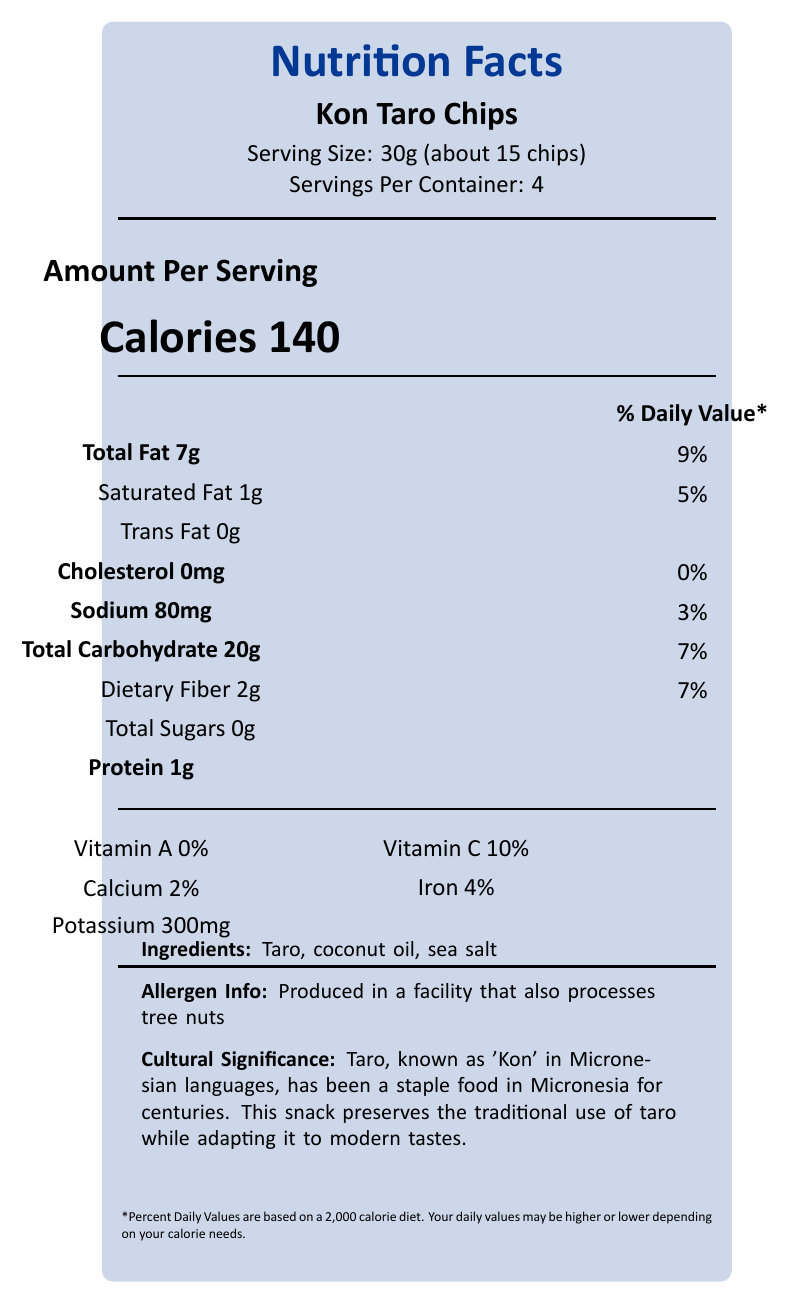what is the serving size? The serving size is stated as "30g (about 15 chips)" in the document.
Answer: 30g (about 15 chips) how many servings are in one container? The number of servings per container is listed as "4" in the document.
Answer: 4 what are the two main ingredients of Kon Taro Chips? The ingredients list mentions "Taro" and "coconut oil" as the first and second ingredients.
Answer: Taro, coconut oil what is the total carbohydrate content per serving? The document lists the total carbohydrate content per serving as "20g".
Answer: 20g how much dietary fiber is in one serving? The document states that the dietary fiber content per serving is "2g".
Answer: 2g which mineral listed in the nutrition facts is present in the highest amount? A. Sodium B. Iron C. Potassium Potassium is listed as "300mg" in the document, which is higher compared to sodium ("80mg") and iron ("4%").
Answer: C. Potassium what is the percentage daily value of saturated fat? A. 5% B. 9% C. 7% D. 3% The percentage daily value (DV) of saturated fat is listed as "5%" in the document.
Answer: A. 5% does Kon Taro Chips contain any trans fat? The document states "Trans Fat 0g," indicating there is no trans fat in the product.
Answer: No is there any cholesterol in Kon Taro Chips? The document shows "Cholesterol 0mg," which means there is no cholesterol in the product.
Answer: No what vitamins and minerals are in Kon Taro Chips? The document lists Vitamin C (10%), calcium (2%), iron (4%), and potassium (300mg).
Answer: Vitamin C, calcium, iron, potassium how should Kon Taro Chips be stored? The storage instructions state to "Store in a cool, dry place. Consume within 2 weeks of opening for best quality."
Answer: Store in a cool, dry place. Consume within 2 weeks of opening for best quality. how does the traditional preparation method enhance the cultural significance of Kon Taro Chips? The document highlights that using traditional methods (hand-slicing, sun-drying, lightly frying in coconut oil) helps preserve cultural traditions.
Answer: The traditional method involves hand-slicing taro roots, sun-drying, and lightly frying in coconut oil, preserving traditional practices while making a modern snack. why might it be challenging to determine if Kon Taro Chips are good for someone with a nut allergy? The allergen information states that the product is "Produced in a facility that also processes tree nuts," which could pose a risk for those with nut allergies.
Answer: Produced in a facility that also processes tree nuts summarize the cultural significance of Kon Taro Chips. The document explains that taro (Kon) has long been a staple in Micronesian diets. The chips preserve this traditional ingredient while appealing to contemporary preferences.
Answer: Taro, known as 'Kon' in Micronesian languages, has been a staple food in Micronesia for centuries. This snack preserves the traditional use of taro while adapting it to modern tastes. who produces the Kon Taro Chips? The document does not provide information about the specific producer of the Kon Taro Chips.
Answer: Not enough information 